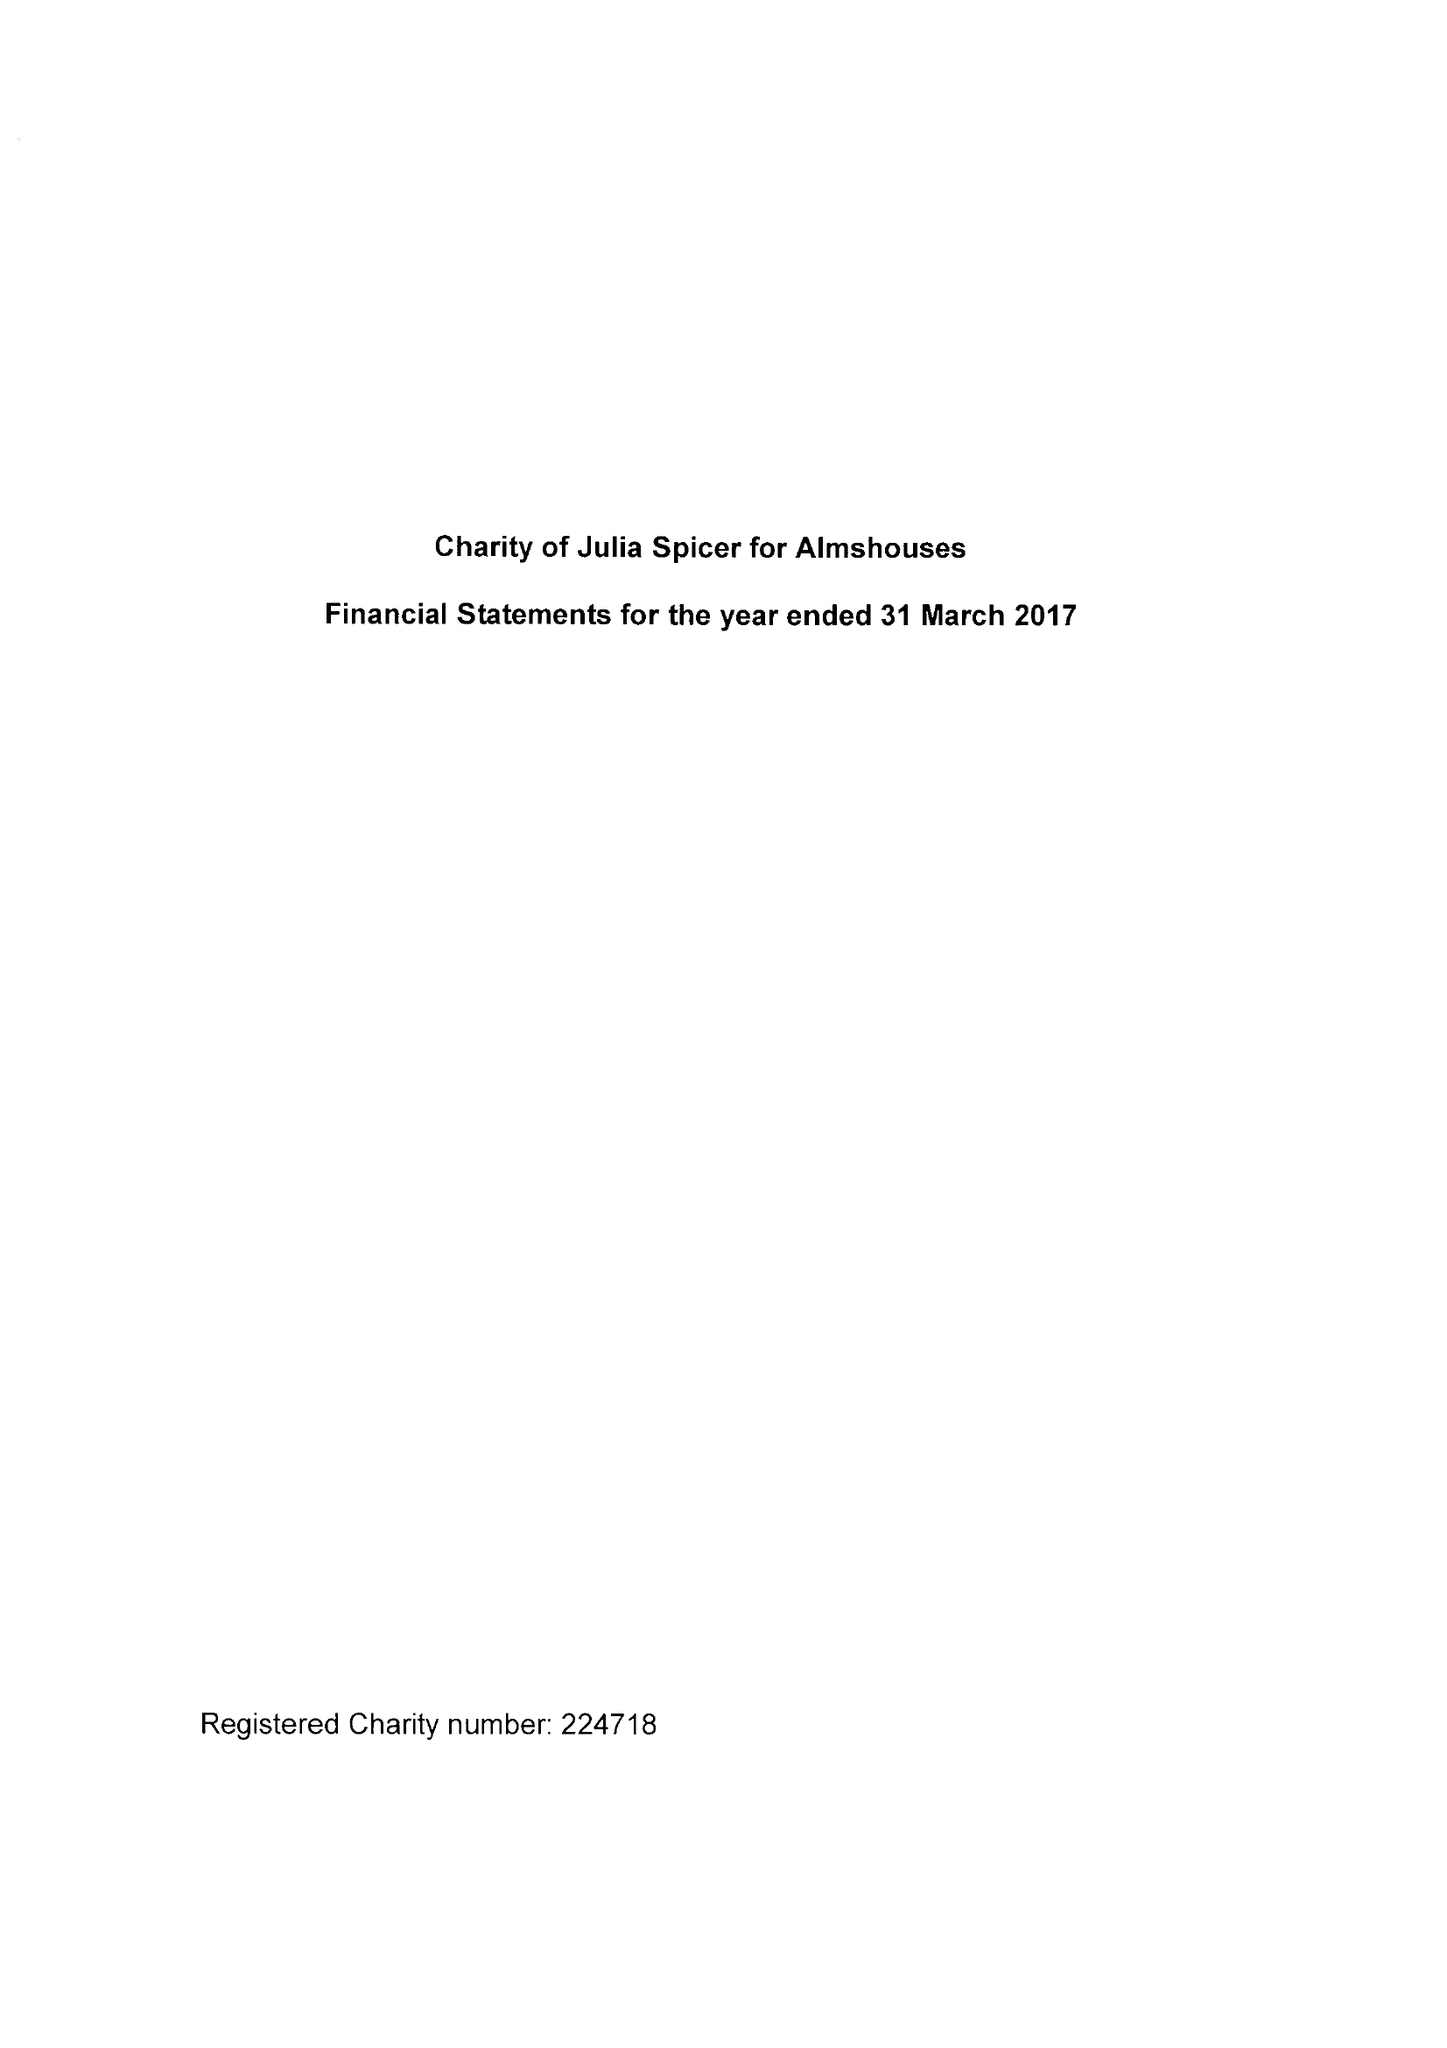What is the value for the address__post_town?
Answer the question using a single word or phrase. CROYDON 